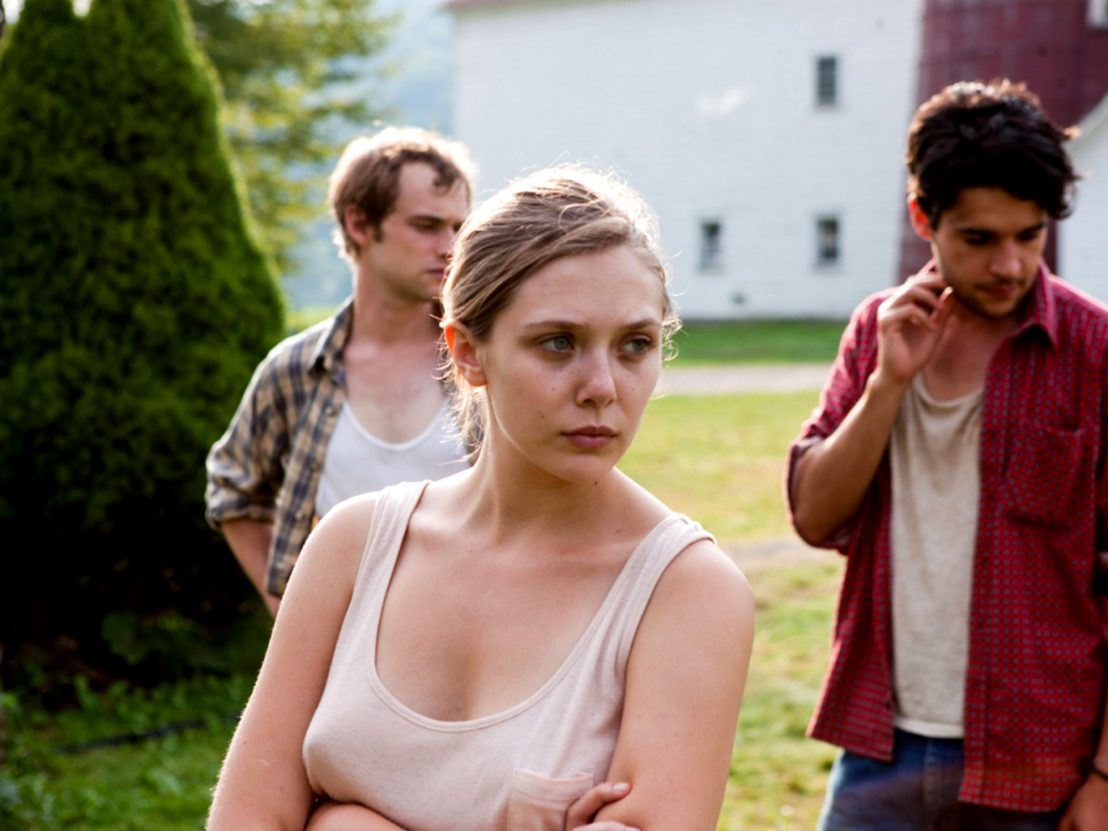Imagine this scene is from a movie. What might the title of the movie be, and what genre would it belong to? The scene could be part of a dramatic movie titled 'Echoes of the Past'. The genre would be a psychological drama, with elements of mystery and suspense. The plot might revolve around hidden secrets and unresolved issues from their past, slowly coming to the surface and affecting their present lives. The pastoral, seemingly serene setting contrasts with the emotional and psychological depth of the characters' struggles, making for a captivating and intense narrative experience. What kind of soundtrack would enhance this scene? A hauntingly beautiful soundtrack with subtle, melancholic piano melodies and soft strings would enhance this scene. The music should build a quiet tension, reflecting the deep emotional undercurrents and the rustic setting. Occasional crescendos could accompany pivotal moments, highlighting the characters' internal struggles and the gravity of their situation. The overall tone of the soundtrack should evoke a mix of nostalgia, sorrow, and suspense, perfectly complementing the visual and emotional atmosphere of the scene. 